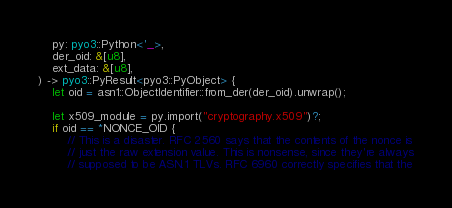Convert code to text. <code><loc_0><loc_0><loc_500><loc_500><_Rust_>    py: pyo3::Python<'_>,
    der_oid: &[u8],
    ext_data: &[u8],
) -> pyo3::PyResult<pyo3::PyObject> {
    let oid = asn1::ObjectIdentifier::from_der(der_oid).unwrap();

    let x509_module = py.import("cryptography.x509")?;
    if oid == *NONCE_OID {
        // This is a disaster. RFC 2560 says that the contents of the nonce is
        // just the raw extension value. This is nonsense, since they're always
        // supposed to be ASN.1 TLVs. RFC 6960 correctly specifies that the</code> 